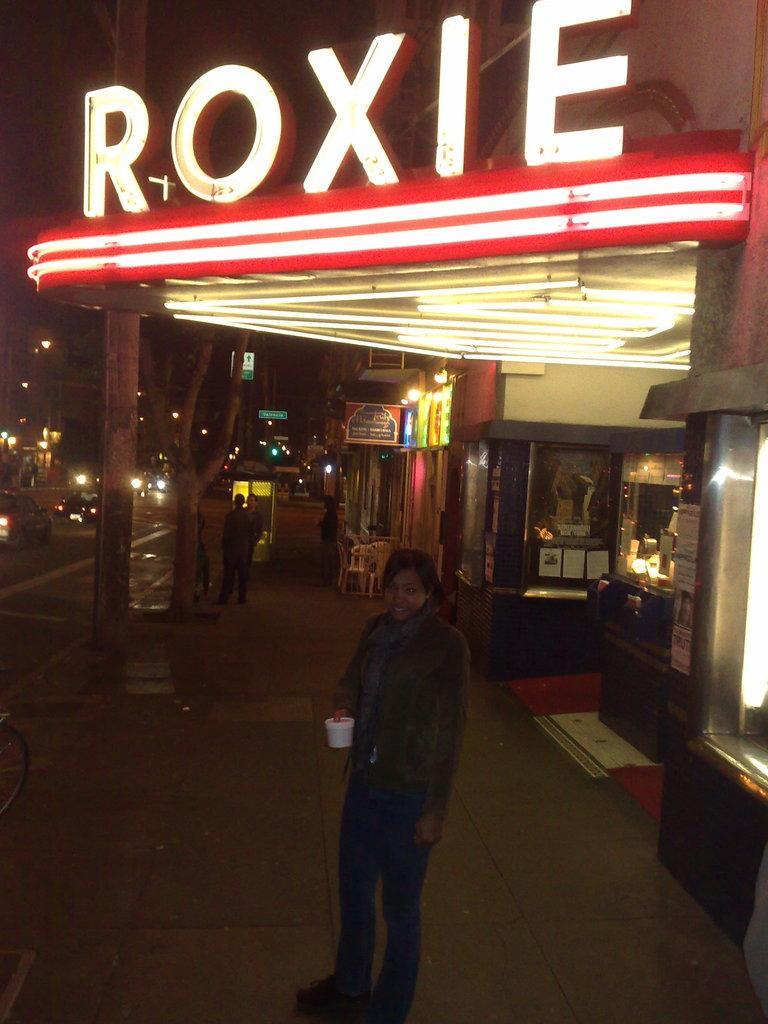In one or two sentences, can you explain what this image depicts? This image consists of a woman standing in the front, she is wearing a jacket and holding a cup. At the top, we can see a name on the building. In the background, there are trees and stalls. At the bottom, there is a road. 